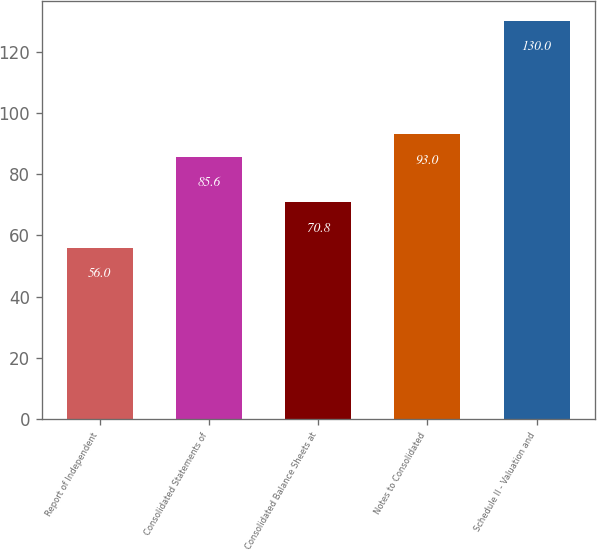<chart> <loc_0><loc_0><loc_500><loc_500><bar_chart><fcel>Report of Independent<fcel>Consolidated Statements of<fcel>Consolidated Balance Sheets at<fcel>Notes to Consolidated<fcel>Schedule II - Valuation and<nl><fcel>56<fcel>85.6<fcel>70.8<fcel>93<fcel>130<nl></chart> 